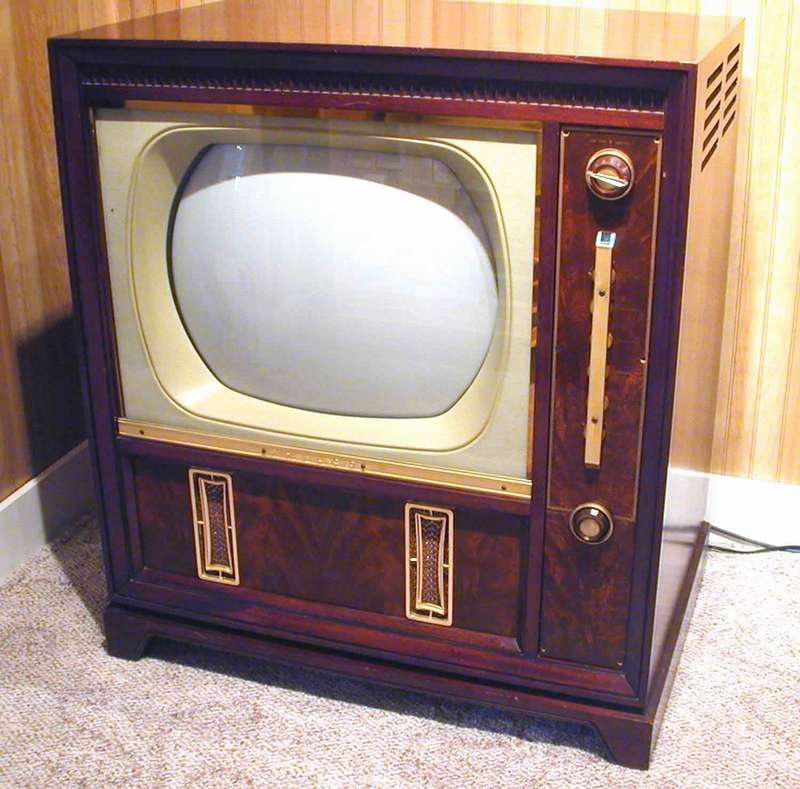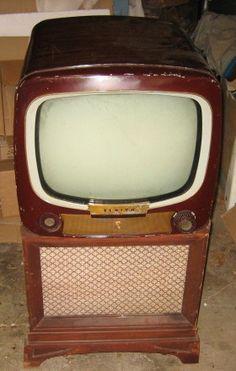The first image is the image on the left, the second image is the image on the right. For the images displayed, is the sentence "An image shows an old-fashioned wood-cased TV set with an oblong screen, elevated with slender tapered wood legs." factually correct? Answer yes or no. No. The first image is the image on the left, the second image is the image on the right. Evaluate the accuracy of this statement regarding the images: "Each of two televisions is contained in the upper section of a wooden cabinet with a speaker area under the television, and two visible control knobs.". Is it true? Answer yes or no. Yes. 